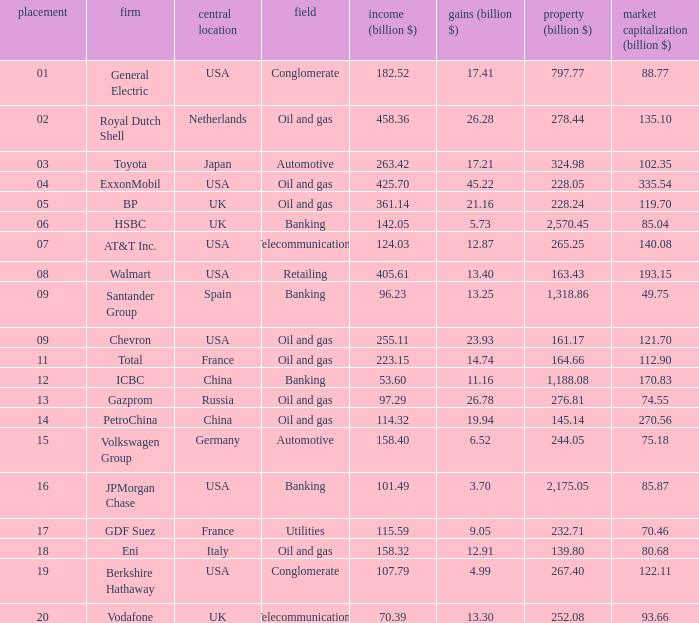Name the Sales (billion $) which have a Company of exxonmobil? 425.7. 